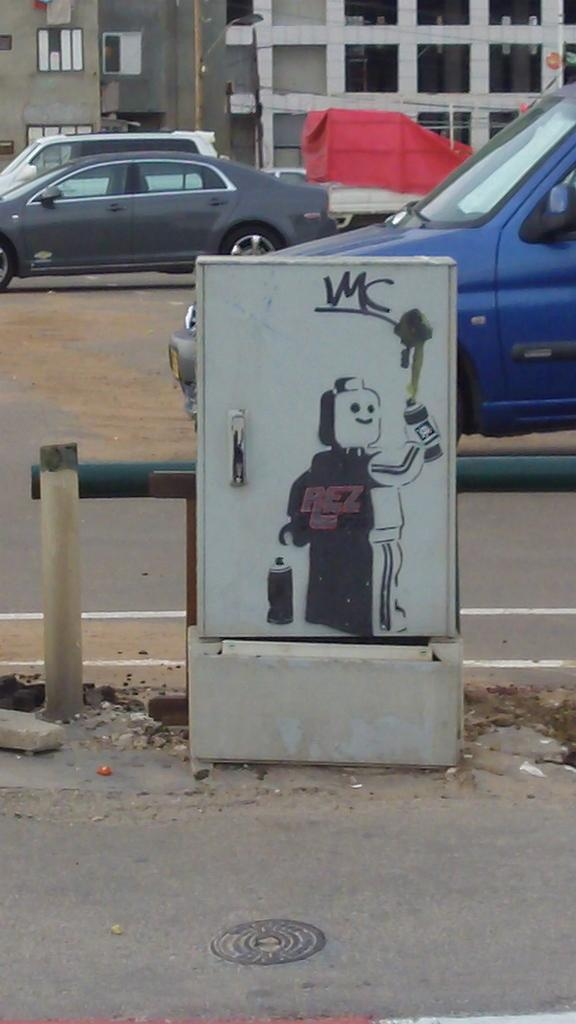What object in the image is white and has art on it? There is a white box in the image with art on it. What can be seen in the image besides the white box? There is a path, cars, buildings in the background, and a red color cloth visible in the image. What type of transportation can be seen in the image? Cars can be seen in the image. What is the color of the cloth in the image? The cloth in the image is red. Where is the scarecrow located in the image? There is no scarecrow present in the image. What type of amusement can be seen in the image? There is no amusement park or any amusement-related objects present in the image. 